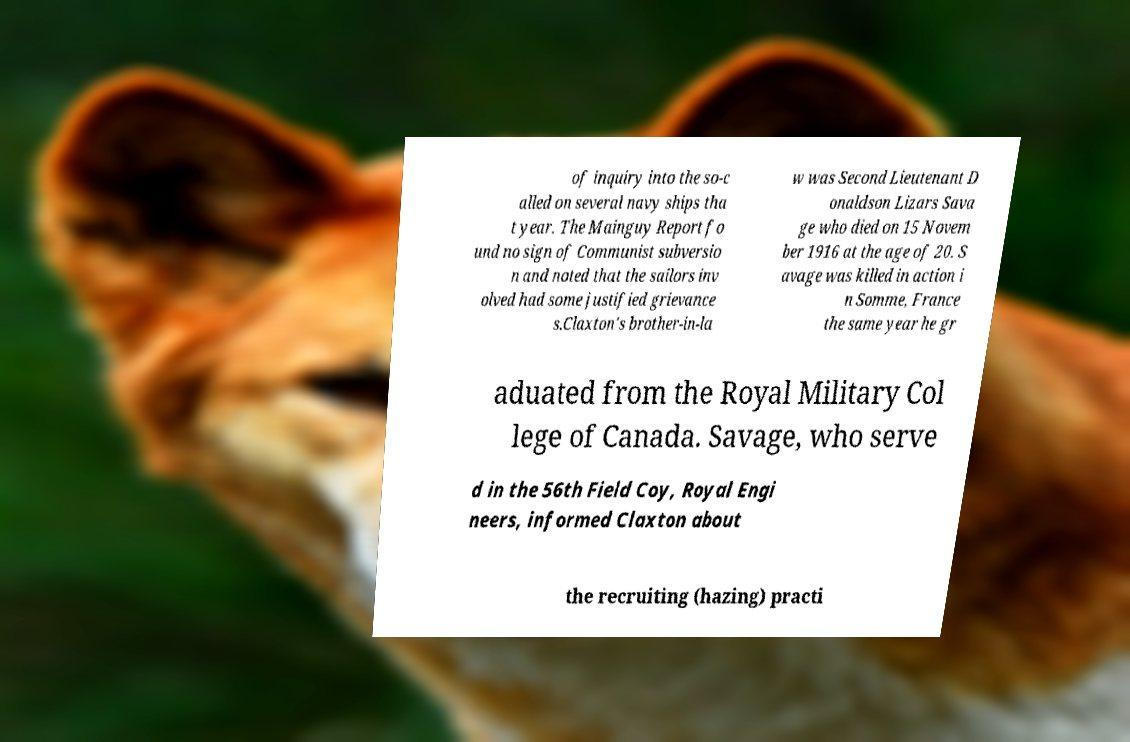For documentation purposes, I need the text within this image transcribed. Could you provide that? of inquiry into the so-c alled on several navy ships tha t year. The Mainguy Report fo und no sign of Communist subversio n and noted that the sailors inv olved had some justified grievance s.Claxton's brother-in-la w was Second Lieutenant D onaldson Lizars Sava ge who died on 15 Novem ber 1916 at the age of 20. S avage was killed in action i n Somme, France the same year he gr aduated from the Royal Military Col lege of Canada. Savage, who serve d in the 56th Field Coy, Royal Engi neers, informed Claxton about the recruiting (hazing) practi 